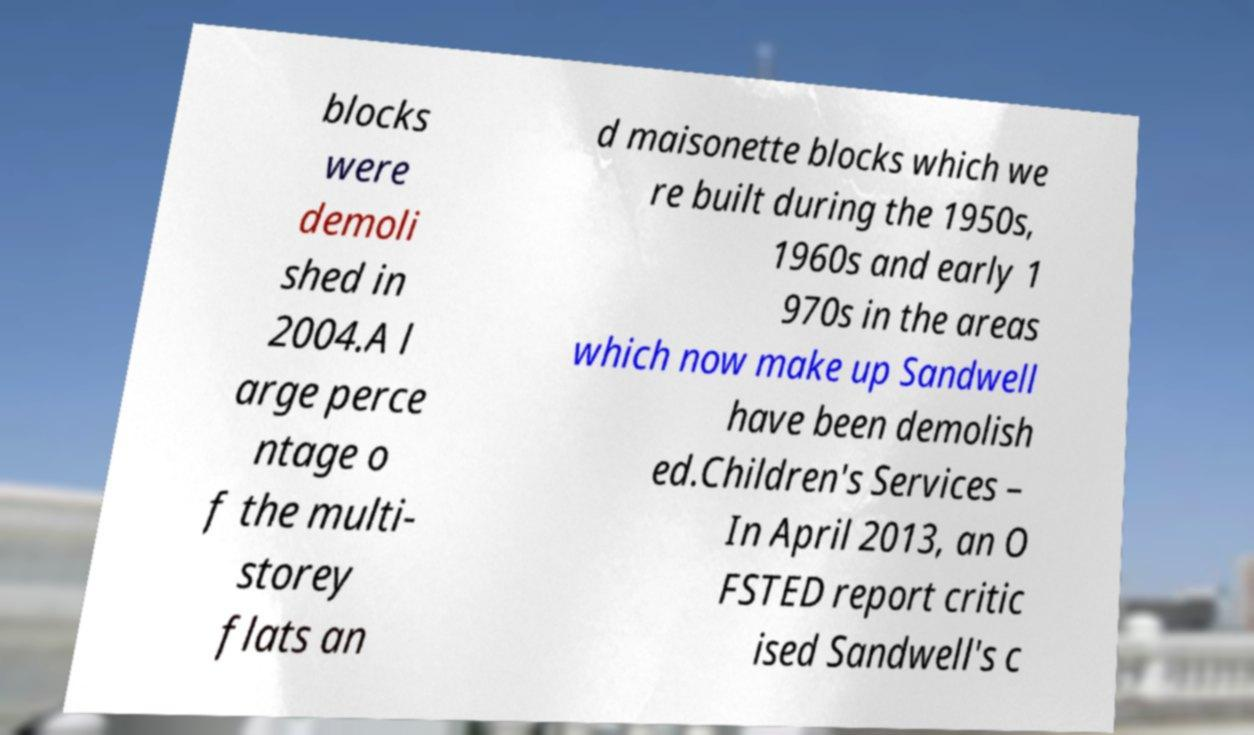Can you accurately transcribe the text from the provided image for me? blocks were demoli shed in 2004.A l arge perce ntage o f the multi- storey flats an d maisonette blocks which we re built during the 1950s, 1960s and early 1 970s in the areas which now make up Sandwell have been demolish ed.Children's Services – In April 2013, an O FSTED report critic ised Sandwell's c 